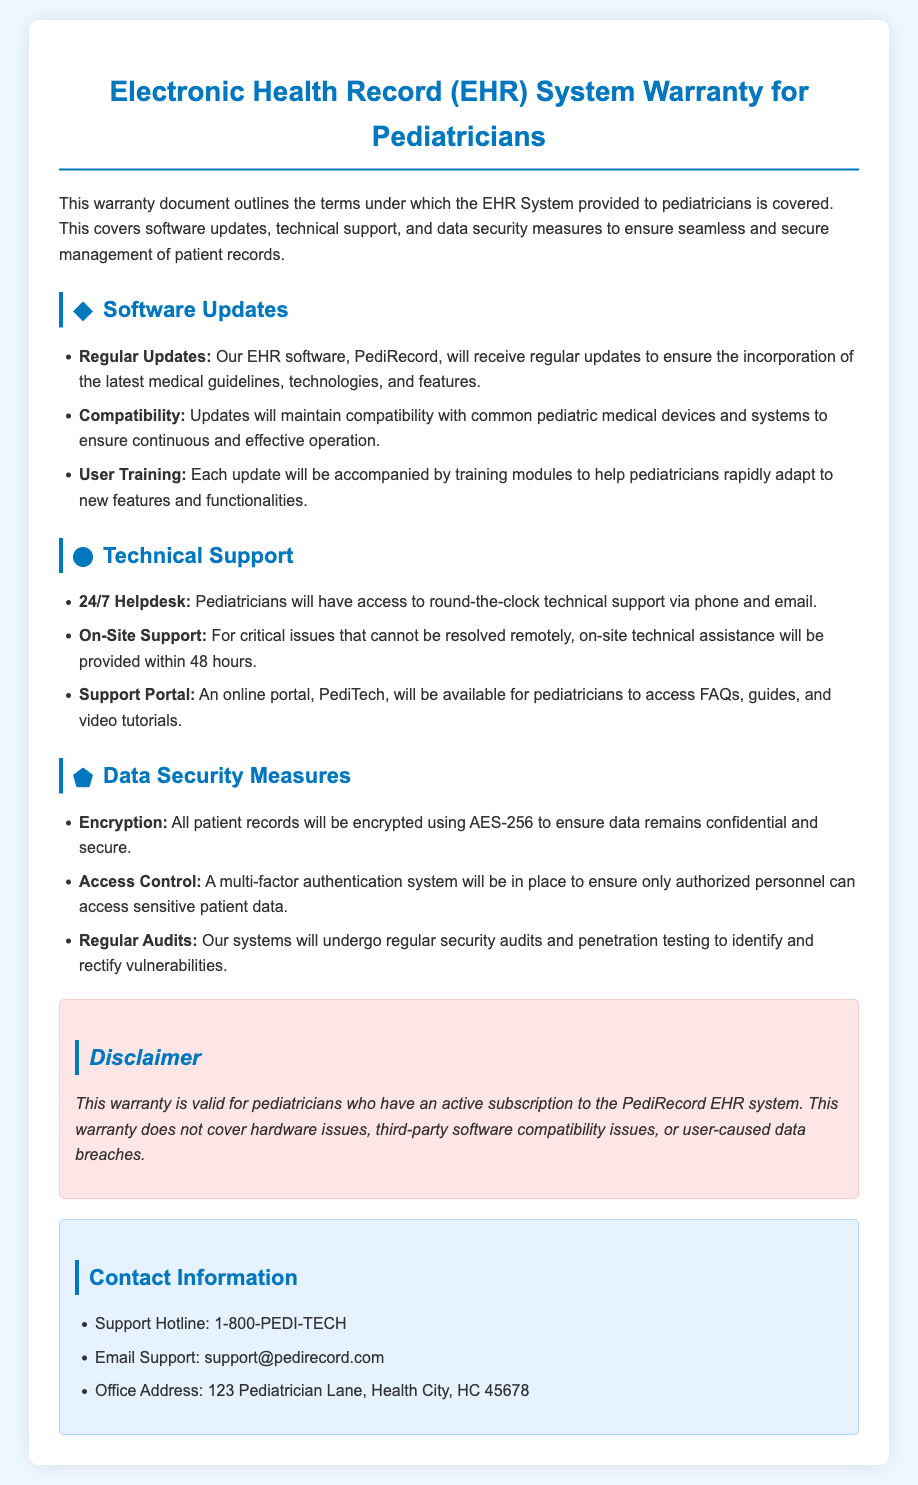What is the name of the EHR software? The document states that the EHR software provided is called PediRecord.
Answer: PediRecord How often will software updates be provided? The document states that the EHR software will receive regular updates.
Answer: Regularly What type of support is available around the clock? The document mentions that pediatricians will have access to a 24/7 helpdesk for technical support.
Answer: 24/7 helpdesk What encryption method is used for patient records? The document specifies that patient records will be encrypted using AES-256.
Answer: AES-256 Within how many hours will on-site support be provided for critical issues? The document states that on-site technical assistance will be provided within 48 hours for critical issues.
Answer: 48 hours What system is in place to ensure only authorized personnel access patient data? The document mentions a multi-factor authentication system as a security measure.
Answer: Multi-factor authentication What is the purpose of the PediTech portal? The document describes the PediTech portal as a resource for accessing FAQs, guides, and video tutorials.
Answer: Access to FAQs and guides What should pediatricians have to validate their warranty? The document states that this warranty is valid for pediatricians who have an active subscription to the PediRecord EHR system.
Answer: Active subscription What is the support hotline number? The document provides the support hotline as 1-800-PEDI-TECH.
Answer: 1-800-PEDI-TECH 